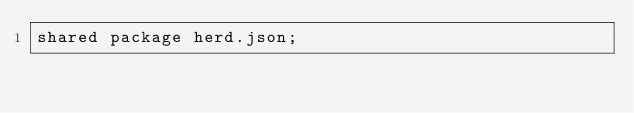Convert code to text. <code><loc_0><loc_0><loc_500><loc_500><_Ceylon_>shared package herd.json;
</code> 